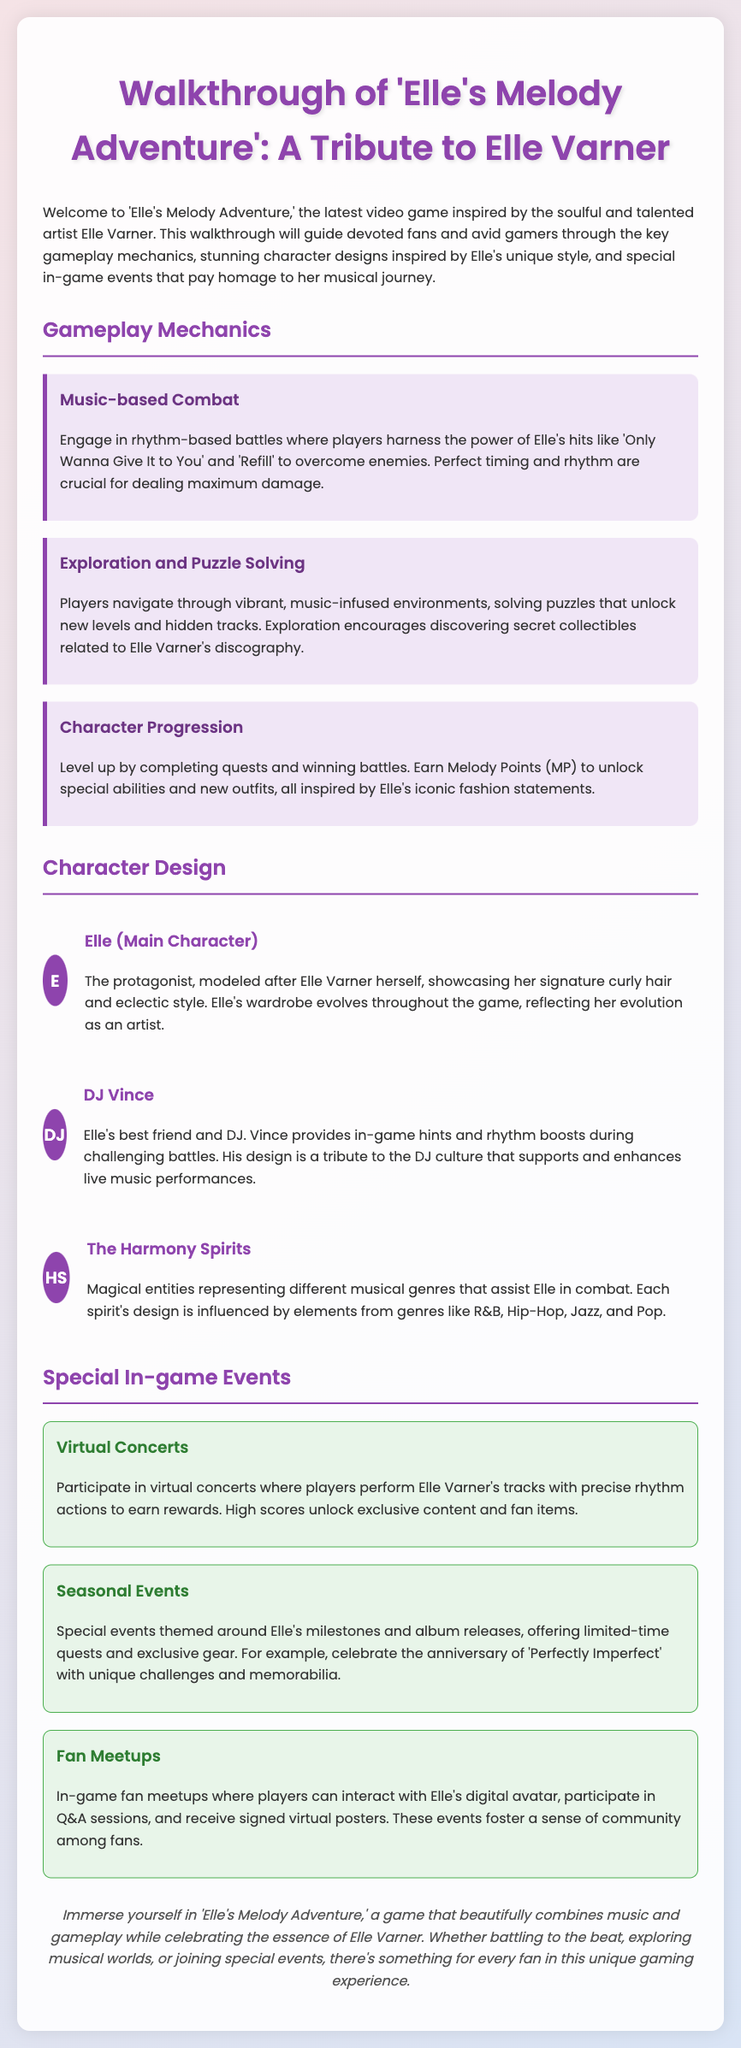What is the title of the game? The title of the game is prominently displayed at the top of the document, focusing on Elle Varner.
Answer: Elle's Melody Adventure What is the main character's name? The main character is introduced in the character design section, modeled after Elle Varner.
Answer: Elle What is the name of Elle's best friend in the game? The character of Elle's best friend is explicitly mentioned along with his role in the gameplay.
Answer: DJ Vince What type of combat is featured in the gameplay? The document describes the main combat mechanic and its relation to music.
Answer: Music-based Combat What are Melody Points used for? Melody Points are mentioned in the context of character progression and their functions.
Answer: Unlock special abilities How are the virtual concerts rewarding? The document explains the gameplay feature and the rewards associated with high scores.
Answer: Earn rewards How many special in-game events are mentioned? The list of special events indicates the variety offered to players in the game.
Answer: Three What do the Harmony Spirits represent? The document describes the purpose and inspiration behind the design of these characters.
Answer: Musical genres What anniversary is celebrated with unique challenges? The document presents a specific event tied to one of Elle Varner's albums.
Answer: Perfectly Imperfect 